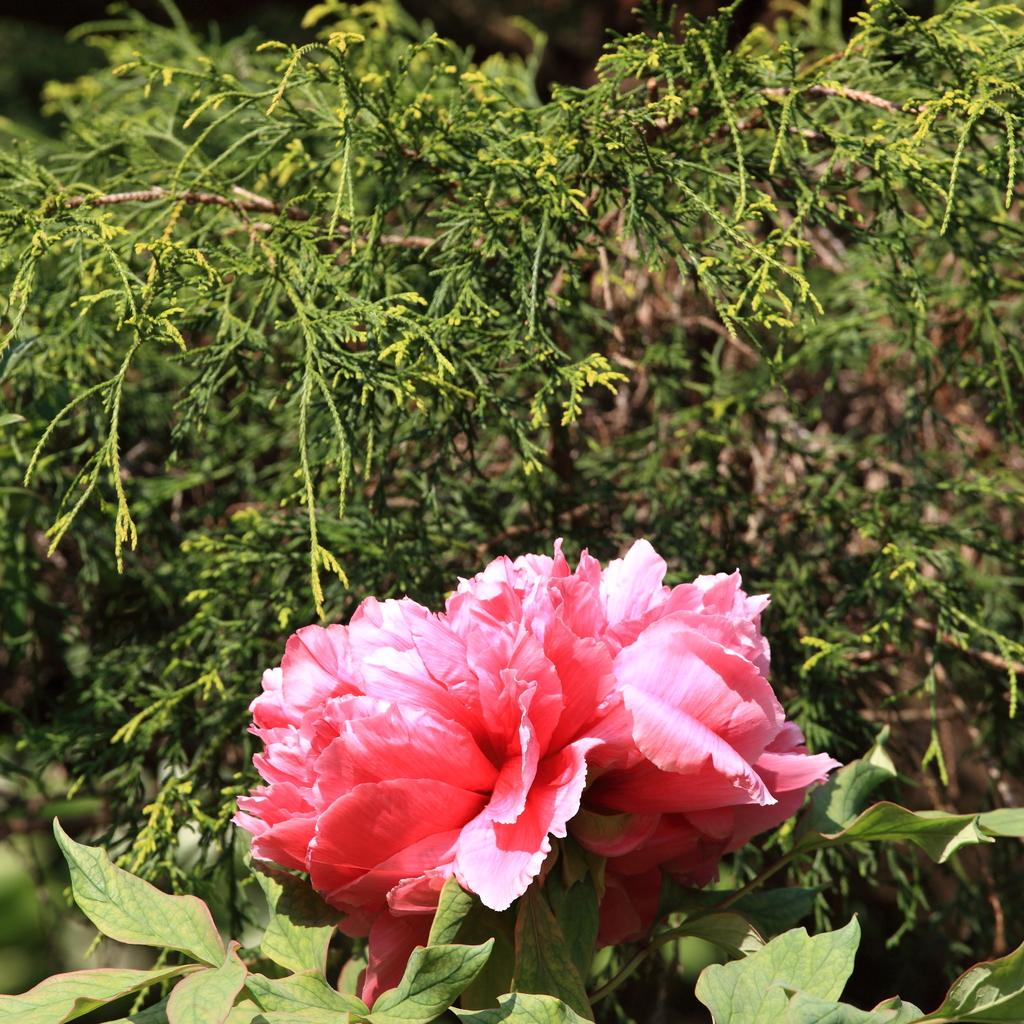What type of living organism can be seen in the image? There is a flower in the image. Are there any other plants visible in the image? Yes, there are plants in the image. What type of prose is being recited by the giraffe in the image? There is no giraffe present in the image, and therefore no prose being recited. 